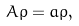<formula> <loc_0><loc_0><loc_500><loc_500>A \varrho = a \varrho ,</formula> 